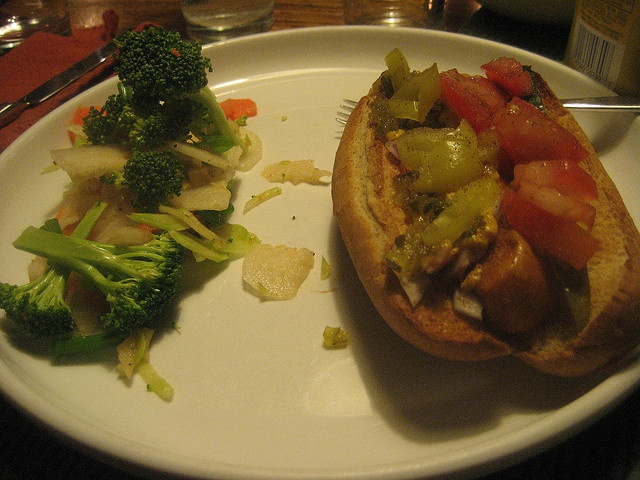Describe the objects in this image and their specific colors. I can see hot dog in black, maroon, and olive tones, broccoli in black, darkgreen, and olive tones, broccoli in black, olive, and darkgreen tones, broccoli in black, olive, and maroon tones, and broccoli in black, olive, and darkgreen tones in this image. 